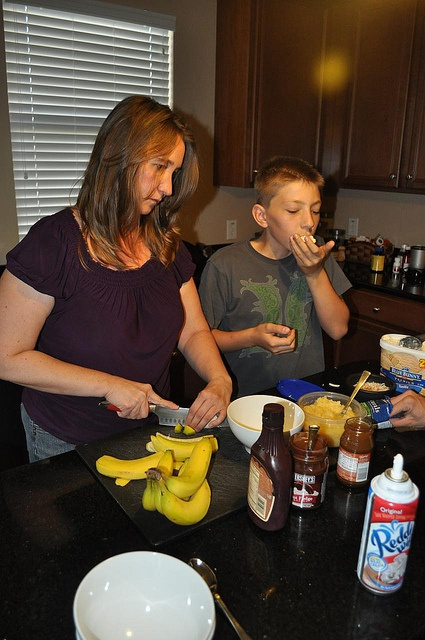Describe the objects in this image and their specific colors. I can see people in black, maroon, tan, and salmon tones, people in black, gray, maroon, and tan tones, bowl in black, lightgray, and darkgray tones, bottle in black, lightgray, darkgray, lightblue, and brown tones, and bottle in black, gray, tan, and maroon tones in this image. 